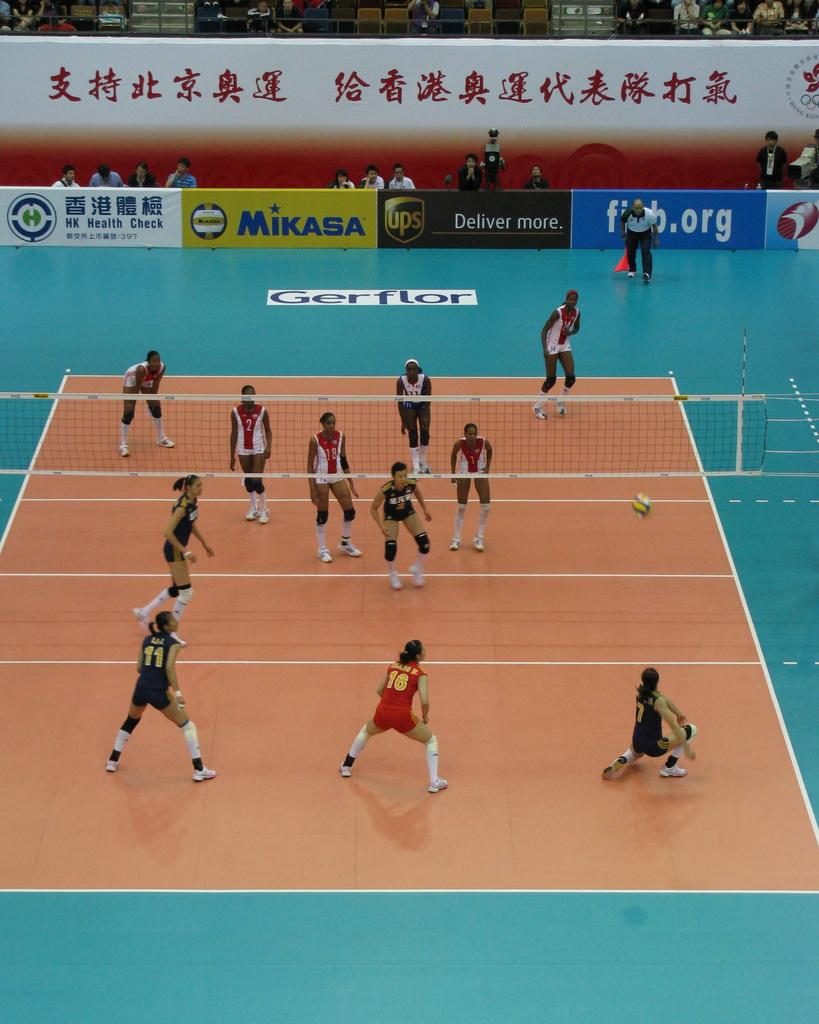<image>
Write a terse but informative summary of the picture. Athletes playing volleyball in a stadium which has an ad for MIKASA. 